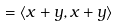Convert formula to latex. <formula><loc_0><loc_0><loc_500><loc_500>= \langle x + y , x + y \rangle</formula> 